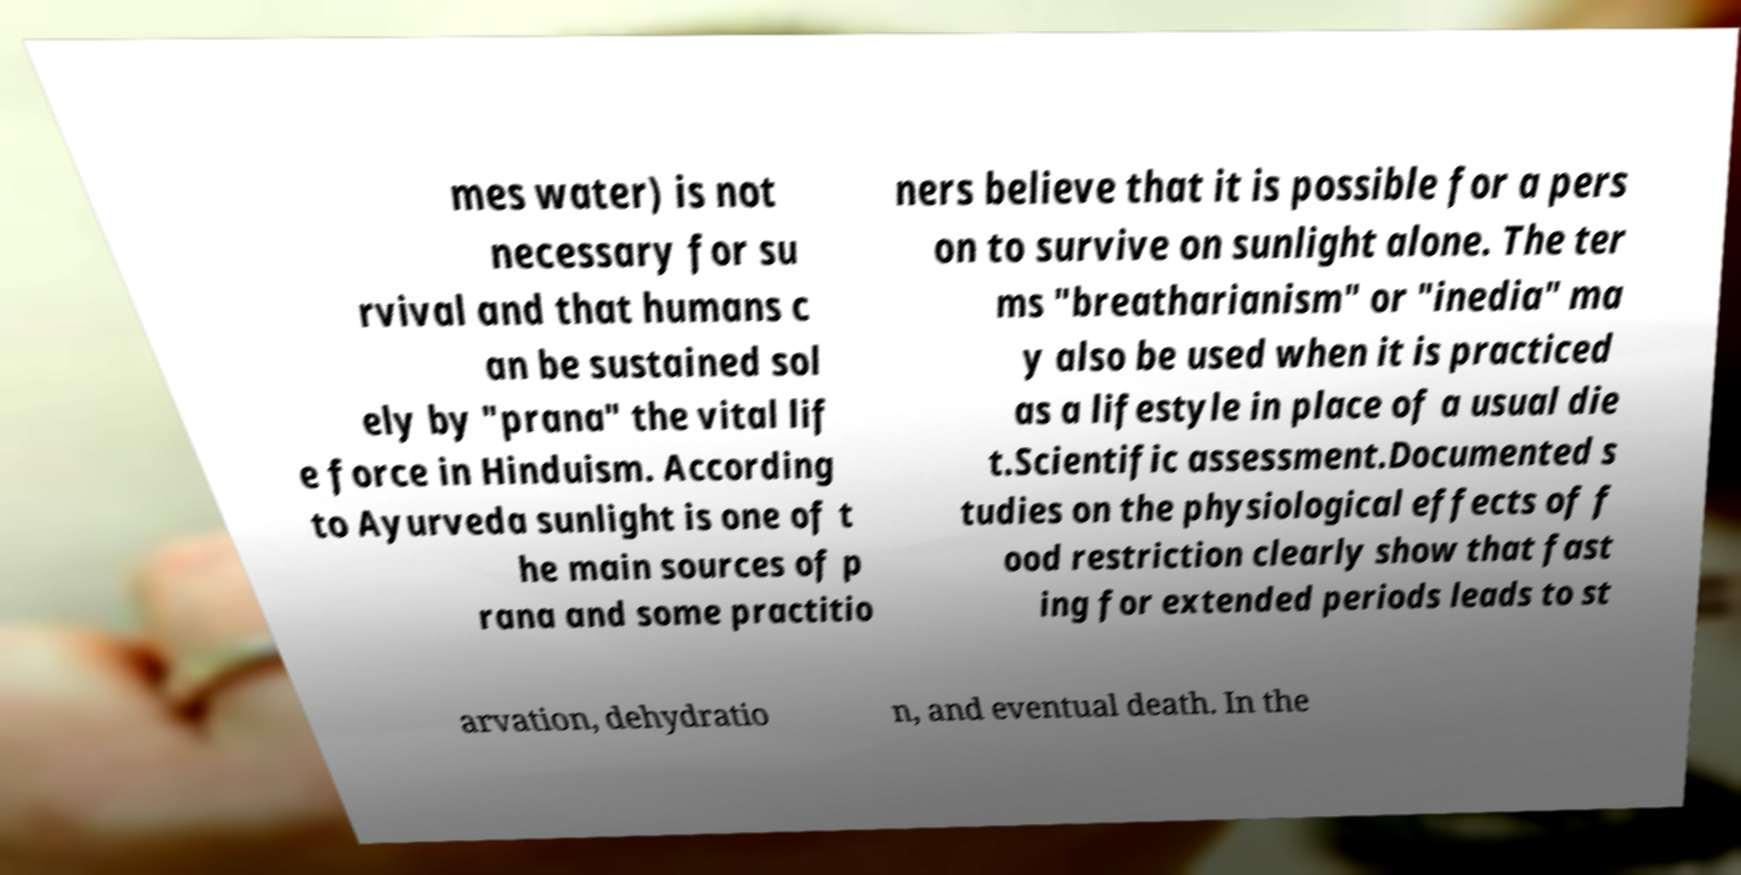Could you extract and type out the text from this image? mes water) is not necessary for su rvival and that humans c an be sustained sol ely by "prana" the vital lif e force in Hinduism. According to Ayurveda sunlight is one of t he main sources of p rana and some practitio ners believe that it is possible for a pers on to survive on sunlight alone. The ter ms "breatharianism" or "inedia" ma y also be used when it is practiced as a lifestyle in place of a usual die t.Scientific assessment.Documented s tudies on the physiological effects of f ood restriction clearly show that fast ing for extended periods leads to st arvation, dehydratio n, and eventual death. In the 